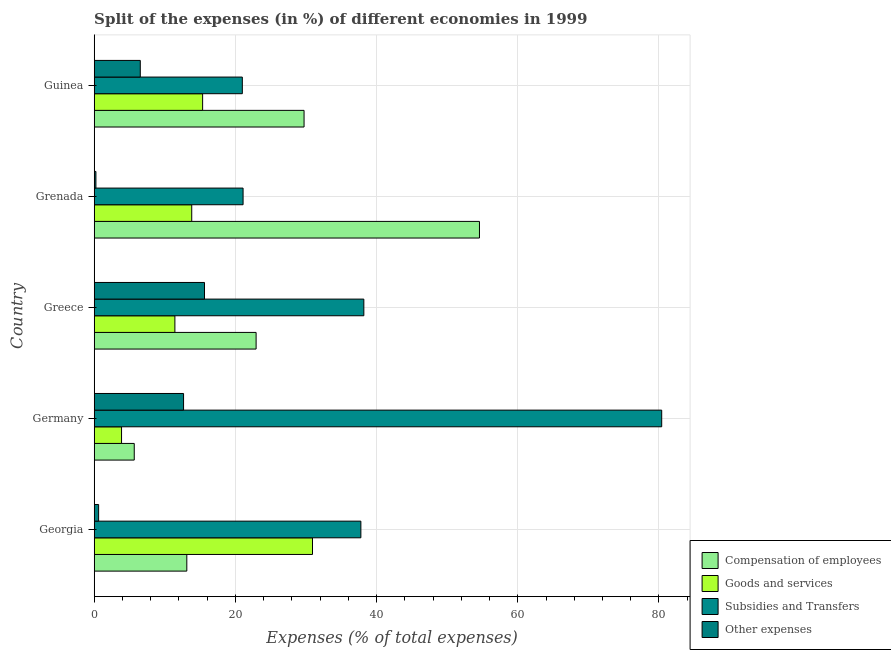What is the label of the 1st group of bars from the top?
Offer a terse response. Guinea. In how many cases, is the number of bars for a given country not equal to the number of legend labels?
Your response must be concise. 0. What is the percentage of amount spent on other expenses in Grenada?
Your response must be concise. 0.24. Across all countries, what is the maximum percentage of amount spent on compensation of employees?
Your answer should be compact. 54.57. Across all countries, what is the minimum percentage of amount spent on other expenses?
Provide a short and direct response. 0.24. In which country was the percentage of amount spent on goods and services maximum?
Your answer should be very brief. Georgia. In which country was the percentage of amount spent on goods and services minimum?
Your response must be concise. Germany. What is the total percentage of amount spent on subsidies in the graph?
Your answer should be very brief. 198.43. What is the difference between the percentage of amount spent on goods and services in Germany and that in Greece?
Offer a terse response. -7.56. What is the difference between the percentage of amount spent on subsidies in Grenada and the percentage of amount spent on compensation of employees in Georgia?
Make the answer very short. 7.97. What is the average percentage of amount spent on compensation of employees per country?
Your answer should be compact. 25.2. What is the difference between the percentage of amount spent on other expenses and percentage of amount spent on compensation of employees in Greece?
Keep it short and to the point. -7.31. In how many countries, is the percentage of amount spent on compensation of employees greater than 80 %?
Provide a short and direct response. 0. What is the ratio of the percentage of amount spent on goods and services in Georgia to that in Germany?
Make the answer very short. 7.98. Is the percentage of amount spent on goods and services in Grenada less than that in Guinea?
Provide a short and direct response. Yes. What is the difference between the highest and the second highest percentage of amount spent on subsidies?
Offer a very short reply. 42.19. What is the difference between the highest and the lowest percentage of amount spent on goods and services?
Keep it short and to the point. 27.05. Is the sum of the percentage of amount spent on compensation of employees in Georgia and Germany greater than the maximum percentage of amount spent on subsidies across all countries?
Your response must be concise. No. What does the 3rd bar from the top in Greece represents?
Give a very brief answer. Goods and services. What does the 2nd bar from the bottom in Greece represents?
Your answer should be very brief. Goods and services. Is it the case that in every country, the sum of the percentage of amount spent on compensation of employees and percentage of amount spent on goods and services is greater than the percentage of amount spent on subsidies?
Your answer should be compact. No. How many bars are there?
Give a very brief answer. 20. Are all the bars in the graph horizontal?
Offer a very short reply. Yes. How many countries are there in the graph?
Your answer should be compact. 5. What is the difference between two consecutive major ticks on the X-axis?
Offer a very short reply. 20. Does the graph contain any zero values?
Your answer should be very brief. No. Where does the legend appear in the graph?
Offer a very short reply. Bottom right. How many legend labels are there?
Give a very brief answer. 4. How are the legend labels stacked?
Provide a succinct answer. Vertical. What is the title of the graph?
Make the answer very short. Split of the expenses (in %) of different economies in 1999. Does "Fish species" appear as one of the legend labels in the graph?
Provide a succinct answer. No. What is the label or title of the X-axis?
Make the answer very short. Expenses (% of total expenses). What is the label or title of the Y-axis?
Your answer should be very brief. Country. What is the Expenses (% of total expenses) of Compensation of employees in Georgia?
Ensure brevity in your answer.  13.12. What is the Expenses (% of total expenses) of Goods and services in Georgia?
Provide a succinct answer. 30.92. What is the Expenses (% of total expenses) in Subsidies and Transfers in Georgia?
Give a very brief answer. 37.78. What is the Expenses (% of total expenses) of Other expenses in Georgia?
Your answer should be compact. 0.63. What is the Expenses (% of total expenses) in Compensation of employees in Germany?
Your answer should be very brief. 5.67. What is the Expenses (% of total expenses) of Goods and services in Germany?
Offer a very short reply. 3.87. What is the Expenses (% of total expenses) of Subsidies and Transfers in Germany?
Offer a terse response. 80.39. What is the Expenses (% of total expenses) of Other expenses in Germany?
Offer a terse response. 12.66. What is the Expenses (% of total expenses) of Compensation of employees in Greece?
Give a very brief answer. 22.93. What is the Expenses (% of total expenses) in Goods and services in Greece?
Give a very brief answer. 11.43. What is the Expenses (% of total expenses) in Subsidies and Transfers in Greece?
Make the answer very short. 38.2. What is the Expenses (% of total expenses) of Other expenses in Greece?
Ensure brevity in your answer.  15.62. What is the Expenses (% of total expenses) in Compensation of employees in Grenada?
Your answer should be compact. 54.57. What is the Expenses (% of total expenses) in Goods and services in Grenada?
Keep it short and to the point. 13.82. What is the Expenses (% of total expenses) in Subsidies and Transfers in Grenada?
Offer a terse response. 21.09. What is the Expenses (% of total expenses) in Other expenses in Grenada?
Your response must be concise. 0.24. What is the Expenses (% of total expenses) of Compensation of employees in Guinea?
Offer a very short reply. 29.73. What is the Expenses (% of total expenses) of Goods and services in Guinea?
Provide a short and direct response. 15.36. What is the Expenses (% of total expenses) of Subsidies and Transfers in Guinea?
Provide a short and direct response. 20.98. What is the Expenses (% of total expenses) of Other expenses in Guinea?
Offer a very short reply. 6.53. Across all countries, what is the maximum Expenses (% of total expenses) in Compensation of employees?
Provide a succinct answer. 54.57. Across all countries, what is the maximum Expenses (% of total expenses) in Goods and services?
Provide a short and direct response. 30.92. Across all countries, what is the maximum Expenses (% of total expenses) in Subsidies and Transfers?
Provide a short and direct response. 80.39. Across all countries, what is the maximum Expenses (% of total expenses) of Other expenses?
Make the answer very short. 15.62. Across all countries, what is the minimum Expenses (% of total expenses) of Compensation of employees?
Make the answer very short. 5.67. Across all countries, what is the minimum Expenses (% of total expenses) of Goods and services?
Make the answer very short. 3.87. Across all countries, what is the minimum Expenses (% of total expenses) of Subsidies and Transfers?
Offer a terse response. 20.98. Across all countries, what is the minimum Expenses (% of total expenses) in Other expenses?
Offer a very short reply. 0.24. What is the total Expenses (% of total expenses) of Compensation of employees in the graph?
Offer a terse response. 126.03. What is the total Expenses (% of total expenses) of Goods and services in the graph?
Your answer should be compact. 75.4. What is the total Expenses (% of total expenses) of Subsidies and Transfers in the graph?
Offer a very short reply. 198.43. What is the total Expenses (% of total expenses) in Other expenses in the graph?
Keep it short and to the point. 35.68. What is the difference between the Expenses (% of total expenses) of Compensation of employees in Georgia and that in Germany?
Offer a terse response. 7.44. What is the difference between the Expenses (% of total expenses) in Goods and services in Georgia and that in Germany?
Offer a terse response. 27.05. What is the difference between the Expenses (% of total expenses) of Subsidies and Transfers in Georgia and that in Germany?
Offer a terse response. -42.61. What is the difference between the Expenses (% of total expenses) of Other expenses in Georgia and that in Germany?
Ensure brevity in your answer.  -12.03. What is the difference between the Expenses (% of total expenses) in Compensation of employees in Georgia and that in Greece?
Keep it short and to the point. -9.82. What is the difference between the Expenses (% of total expenses) of Goods and services in Georgia and that in Greece?
Keep it short and to the point. 19.49. What is the difference between the Expenses (% of total expenses) of Subsidies and Transfers in Georgia and that in Greece?
Your response must be concise. -0.42. What is the difference between the Expenses (% of total expenses) in Other expenses in Georgia and that in Greece?
Provide a short and direct response. -15. What is the difference between the Expenses (% of total expenses) in Compensation of employees in Georgia and that in Grenada?
Keep it short and to the point. -41.46. What is the difference between the Expenses (% of total expenses) in Goods and services in Georgia and that in Grenada?
Provide a succinct answer. 17.11. What is the difference between the Expenses (% of total expenses) in Subsidies and Transfers in Georgia and that in Grenada?
Keep it short and to the point. 16.69. What is the difference between the Expenses (% of total expenses) of Other expenses in Georgia and that in Grenada?
Ensure brevity in your answer.  0.38. What is the difference between the Expenses (% of total expenses) of Compensation of employees in Georgia and that in Guinea?
Provide a succinct answer. -16.61. What is the difference between the Expenses (% of total expenses) in Goods and services in Georgia and that in Guinea?
Make the answer very short. 15.56. What is the difference between the Expenses (% of total expenses) of Subsidies and Transfers in Georgia and that in Guinea?
Provide a succinct answer. 16.79. What is the difference between the Expenses (% of total expenses) of Other expenses in Georgia and that in Guinea?
Your answer should be very brief. -5.9. What is the difference between the Expenses (% of total expenses) of Compensation of employees in Germany and that in Greece?
Provide a short and direct response. -17.26. What is the difference between the Expenses (% of total expenses) of Goods and services in Germany and that in Greece?
Your answer should be very brief. -7.56. What is the difference between the Expenses (% of total expenses) in Subsidies and Transfers in Germany and that in Greece?
Provide a short and direct response. 42.19. What is the difference between the Expenses (% of total expenses) in Other expenses in Germany and that in Greece?
Give a very brief answer. -2.97. What is the difference between the Expenses (% of total expenses) in Compensation of employees in Germany and that in Grenada?
Your answer should be very brief. -48.9. What is the difference between the Expenses (% of total expenses) of Goods and services in Germany and that in Grenada?
Give a very brief answer. -9.94. What is the difference between the Expenses (% of total expenses) of Subsidies and Transfers in Germany and that in Grenada?
Offer a terse response. 59.3. What is the difference between the Expenses (% of total expenses) of Other expenses in Germany and that in Grenada?
Your response must be concise. 12.41. What is the difference between the Expenses (% of total expenses) in Compensation of employees in Germany and that in Guinea?
Your answer should be very brief. -24.05. What is the difference between the Expenses (% of total expenses) in Goods and services in Germany and that in Guinea?
Make the answer very short. -11.48. What is the difference between the Expenses (% of total expenses) in Subsidies and Transfers in Germany and that in Guinea?
Your answer should be compact. 59.41. What is the difference between the Expenses (% of total expenses) in Other expenses in Germany and that in Guinea?
Give a very brief answer. 6.13. What is the difference between the Expenses (% of total expenses) in Compensation of employees in Greece and that in Grenada?
Ensure brevity in your answer.  -31.64. What is the difference between the Expenses (% of total expenses) of Goods and services in Greece and that in Grenada?
Ensure brevity in your answer.  -2.38. What is the difference between the Expenses (% of total expenses) of Subsidies and Transfers in Greece and that in Grenada?
Keep it short and to the point. 17.11. What is the difference between the Expenses (% of total expenses) of Other expenses in Greece and that in Grenada?
Make the answer very short. 15.38. What is the difference between the Expenses (% of total expenses) of Compensation of employees in Greece and that in Guinea?
Your answer should be compact. -6.79. What is the difference between the Expenses (% of total expenses) of Goods and services in Greece and that in Guinea?
Your response must be concise. -3.93. What is the difference between the Expenses (% of total expenses) in Subsidies and Transfers in Greece and that in Guinea?
Your answer should be compact. 17.21. What is the difference between the Expenses (% of total expenses) in Other expenses in Greece and that in Guinea?
Ensure brevity in your answer.  9.1. What is the difference between the Expenses (% of total expenses) in Compensation of employees in Grenada and that in Guinea?
Offer a very short reply. 24.85. What is the difference between the Expenses (% of total expenses) of Goods and services in Grenada and that in Guinea?
Provide a short and direct response. -1.54. What is the difference between the Expenses (% of total expenses) in Subsidies and Transfers in Grenada and that in Guinea?
Keep it short and to the point. 0.11. What is the difference between the Expenses (% of total expenses) of Other expenses in Grenada and that in Guinea?
Provide a short and direct response. -6.28. What is the difference between the Expenses (% of total expenses) of Compensation of employees in Georgia and the Expenses (% of total expenses) of Goods and services in Germany?
Provide a succinct answer. 9.24. What is the difference between the Expenses (% of total expenses) of Compensation of employees in Georgia and the Expenses (% of total expenses) of Subsidies and Transfers in Germany?
Your response must be concise. -67.27. What is the difference between the Expenses (% of total expenses) of Compensation of employees in Georgia and the Expenses (% of total expenses) of Other expenses in Germany?
Your answer should be very brief. 0.46. What is the difference between the Expenses (% of total expenses) of Goods and services in Georgia and the Expenses (% of total expenses) of Subsidies and Transfers in Germany?
Offer a terse response. -49.47. What is the difference between the Expenses (% of total expenses) in Goods and services in Georgia and the Expenses (% of total expenses) in Other expenses in Germany?
Ensure brevity in your answer.  18.26. What is the difference between the Expenses (% of total expenses) of Subsidies and Transfers in Georgia and the Expenses (% of total expenses) of Other expenses in Germany?
Provide a short and direct response. 25.12. What is the difference between the Expenses (% of total expenses) of Compensation of employees in Georgia and the Expenses (% of total expenses) of Goods and services in Greece?
Your answer should be very brief. 1.69. What is the difference between the Expenses (% of total expenses) of Compensation of employees in Georgia and the Expenses (% of total expenses) of Subsidies and Transfers in Greece?
Make the answer very short. -25.08. What is the difference between the Expenses (% of total expenses) of Compensation of employees in Georgia and the Expenses (% of total expenses) of Other expenses in Greece?
Offer a terse response. -2.51. What is the difference between the Expenses (% of total expenses) in Goods and services in Georgia and the Expenses (% of total expenses) in Subsidies and Transfers in Greece?
Offer a terse response. -7.27. What is the difference between the Expenses (% of total expenses) in Goods and services in Georgia and the Expenses (% of total expenses) in Other expenses in Greece?
Your response must be concise. 15.3. What is the difference between the Expenses (% of total expenses) of Subsidies and Transfers in Georgia and the Expenses (% of total expenses) of Other expenses in Greece?
Provide a short and direct response. 22.15. What is the difference between the Expenses (% of total expenses) of Compensation of employees in Georgia and the Expenses (% of total expenses) of Goods and services in Grenada?
Your answer should be very brief. -0.7. What is the difference between the Expenses (% of total expenses) in Compensation of employees in Georgia and the Expenses (% of total expenses) in Subsidies and Transfers in Grenada?
Make the answer very short. -7.97. What is the difference between the Expenses (% of total expenses) of Compensation of employees in Georgia and the Expenses (% of total expenses) of Other expenses in Grenada?
Provide a succinct answer. 12.87. What is the difference between the Expenses (% of total expenses) of Goods and services in Georgia and the Expenses (% of total expenses) of Subsidies and Transfers in Grenada?
Your response must be concise. 9.83. What is the difference between the Expenses (% of total expenses) in Goods and services in Georgia and the Expenses (% of total expenses) in Other expenses in Grenada?
Your response must be concise. 30.68. What is the difference between the Expenses (% of total expenses) of Subsidies and Transfers in Georgia and the Expenses (% of total expenses) of Other expenses in Grenada?
Your answer should be compact. 37.53. What is the difference between the Expenses (% of total expenses) in Compensation of employees in Georgia and the Expenses (% of total expenses) in Goods and services in Guinea?
Offer a very short reply. -2.24. What is the difference between the Expenses (% of total expenses) of Compensation of employees in Georgia and the Expenses (% of total expenses) of Subsidies and Transfers in Guinea?
Your response must be concise. -7.86. What is the difference between the Expenses (% of total expenses) in Compensation of employees in Georgia and the Expenses (% of total expenses) in Other expenses in Guinea?
Keep it short and to the point. 6.59. What is the difference between the Expenses (% of total expenses) in Goods and services in Georgia and the Expenses (% of total expenses) in Subsidies and Transfers in Guinea?
Keep it short and to the point. 9.94. What is the difference between the Expenses (% of total expenses) of Goods and services in Georgia and the Expenses (% of total expenses) of Other expenses in Guinea?
Provide a succinct answer. 24.39. What is the difference between the Expenses (% of total expenses) in Subsidies and Transfers in Georgia and the Expenses (% of total expenses) in Other expenses in Guinea?
Offer a terse response. 31.25. What is the difference between the Expenses (% of total expenses) of Compensation of employees in Germany and the Expenses (% of total expenses) of Goods and services in Greece?
Make the answer very short. -5.76. What is the difference between the Expenses (% of total expenses) of Compensation of employees in Germany and the Expenses (% of total expenses) of Subsidies and Transfers in Greece?
Make the answer very short. -32.52. What is the difference between the Expenses (% of total expenses) of Compensation of employees in Germany and the Expenses (% of total expenses) of Other expenses in Greece?
Offer a very short reply. -9.95. What is the difference between the Expenses (% of total expenses) of Goods and services in Germany and the Expenses (% of total expenses) of Subsidies and Transfers in Greece?
Your answer should be compact. -34.32. What is the difference between the Expenses (% of total expenses) of Goods and services in Germany and the Expenses (% of total expenses) of Other expenses in Greece?
Your response must be concise. -11.75. What is the difference between the Expenses (% of total expenses) in Subsidies and Transfers in Germany and the Expenses (% of total expenses) in Other expenses in Greece?
Your response must be concise. 64.77. What is the difference between the Expenses (% of total expenses) of Compensation of employees in Germany and the Expenses (% of total expenses) of Goods and services in Grenada?
Make the answer very short. -8.14. What is the difference between the Expenses (% of total expenses) in Compensation of employees in Germany and the Expenses (% of total expenses) in Subsidies and Transfers in Grenada?
Make the answer very short. -15.42. What is the difference between the Expenses (% of total expenses) of Compensation of employees in Germany and the Expenses (% of total expenses) of Other expenses in Grenada?
Give a very brief answer. 5.43. What is the difference between the Expenses (% of total expenses) of Goods and services in Germany and the Expenses (% of total expenses) of Subsidies and Transfers in Grenada?
Your answer should be very brief. -17.21. What is the difference between the Expenses (% of total expenses) of Goods and services in Germany and the Expenses (% of total expenses) of Other expenses in Grenada?
Your answer should be very brief. 3.63. What is the difference between the Expenses (% of total expenses) of Subsidies and Transfers in Germany and the Expenses (% of total expenses) of Other expenses in Grenada?
Provide a succinct answer. 80.15. What is the difference between the Expenses (% of total expenses) in Compensation of employees in Germany and the Expenses (% of total expenses) in Goods and services in Guinea?
Provide a succinct answer. -9.68. What is the difference between the Expenses (% of total expenses) in Compensation of employees in Germany and the Expenses (% of total expenses) in Subsidies and Transfers in Guinea?
Make the answer very short. -15.31. What is the difference between the Expenses (% of total expenses) in Compensation of employees in Germany and the Expenses (% of total expenses) in Other expenses in Guinea?
Your answer should be compact. -0.85. What is the difference between the Expenses (% of total expenses) of Goods and services in Germany and the Expenses (% of total expenses) of Subsidies and Transfers in Guinea?
Offer a terse response. -17.11. What is the difference between the Expenses (% of total expenses) in Goods and services in Germany and the Expenses (% of total expenses) in Other expenses in Guinea?
Offer a terse response. -2.65. What is the difference between the Expenses (% of total expenses) in Subsidies and Transfers in Germany and the Expenses (% of total expenses) in Other expenses in Guinea?
Your answer should be compact. 73.86. What is the difference between the Expenses (% of total expenses) in Compensation of employees in Greece and the Expenses (% of total expenses) in Goods and services in Grenada?
Keep it short and to the point. 9.12. What is the difference between the Expenses (% of total expenses) of Compensation of employees in Greece and the Expenses (% of total expenses) of Subsidies and Transfers in Grenada?
Keep it short and to the point. 1.85. What is the difference between the Expenses (% of total expenses) in Compensation of employees in Greece and the Expenses (% of total expenses) in Other expenses in Grenada?
Give a very brief answer. 22.69. What is the difference between the Expenses (% of total expenses) in Goods and services in Greece and the Expenses (% of total expenses) in Subsidies and Transfers in Grenada?
Keep it short and to the point. -9.66. What is the difference between the Expenses (% of total expenses) in Goods and services in Greece and the Expenses (% of total expenses) in Other expenses in Grenada?
Make the answer very short. 11.19. What is the difference between the Expenses (% of total expenses) of Subsidies and Transfers in Greece and the Expenses (% of total expenses) of Other expenses in Grenada?
Provide a short and direct response. 37.95. What is the difference between the Expenses (% of total expenses) in Compensation of employees in Greece and the Expenses (% of total expenses) in Goods and services in Guinea?
Provide a succinct answer. 7.58. What is the difference between the Expenses (% of total expenses) of Compensation of employees in Greece and the Expenses (% of total expenses) of Subsidies and Transfers in Guinea?
Provide a succinct answer. 1.95. What is the difference between the Expenses (% of total expenses) of Compensation of employees in Greece and the Expenses (% of total expenses) of Other expenses in Guinea?
Make the answer very short. 16.41. What is the difference between the Expenses (% of total expenses) of Goods and services in Greece and the Expenses (% of total expenses) of Subsidies and Transfers in Guinea?
Provide a short and direct response. -9.55. What is the difference between the Expenses (% of total expenses) in Goods and services in Greece and the Expenses (% of total expenses) in Other expenses in Guinea?
Your answer should be compact. 4.9. What is the difference between the Expenses (% of total expenses) of Subsidies and Transfers in Greece and the Expenses (% of total expenses) of Other expenses in Guinea?
Provide a short and direct response. 31.67. What is the difference between the Expenses (% of total expenses) in Compensation of employees in Grenada and the Expenses (% of total expenses) in Goods and services in Guinea?
Offer a terse response. 39.22. What is the difference between the Expenses (% of total expenses) in Compensation of employees in Grenada and the Expenses (% of total expenses) in Subsidies and Transfers in Guinea?
Your answer should be very brief. 33.59. What is the difference between the Expenses (% of total expenses) in Compensation of employees in Grenada and the Expenses (% of total expenses) in Other expenses in Guinea?
Keep it short and to the point. 48.05. What is the difference between the Expenses (% of total expenses) in Goods and services in Grenada and the Expenses (% of total expenses) in Subsidies and Transfers in Guinea?
Keep it short and to the point. -7.17. What is the difference between the Expenses (% of total expenses) in Goods and services in Grenada and the Expenses (% of total expenses) in Other expenses in Guinea?
Provide a short and direct response. 7.29. What is the difference between the Expenses (% of total expenses) of Subsidies and Transfers in Grenada and the Expenses (% of total expenses) of Other expenses in Guinea?
Your answer should be very brief. 14.56. What is the average Expenses (% of total expenses) of Compensation of employees per country?
Your answer should be very brief. 25.21. What is the average Expenses (% of total expenses) of Goods and services per country?
Ensure brevity in your answer.  15.08. What is the average Expenses (% of total expenses) of Subsidies and Transfers per country?
Your response must be concise. 39.69. What is the average Expenses (% of total expenses) of Other expenses per country?
Ensure brevity in your answer.  7.14. What is the difference between the Expenses (% of total expenses) of Compensation of employees and Expenses (% of total expenses) of Goods and services in Georgia?
Provide a short and direct response. -17.8. What is the difference between the Expenses (% of total expenses) of Compensation of employees and Expenses (% of total expenses) of Subsidies and Transfers in Georgia?
Your answer should be very brief. -24.66. What is the difference between the Expenses (% of total expenses) in Compensation of employees and Expenses (% of total expenses) in Other expenses in Georgia?
Ensure brevity in your answer.  12.49. What is the difference between the Expenses (% of total expenses) of Goods and services and Expenses (% of total expenses) of Subsidies and Transfers in Georgia?
Keep it short and to the point. -6.85. What is the difference between the Expenses (% of total expenses) in Goods and services and Expenses (% of total expenses) in Other expenses in Georgia?
Ensure brevity in your answer.  30.3. What is the difference between the Expenses (% of total expenses) in Subsidies and Transfers and Expenses (% of total expenses) in Other expenses in Georgia?
Keep it short and to the point. 37.15. What is the difference between the Expenses (% of total expenses) in Compensation of employees and Expenses (% of total expenses) in Goods and services in Germany?
Provide a short and direct response. 1.8. What is the difference between the Expenses (% of total expenses) of Compensation of employees and Expenses (% of total expenses) of Subsidies and Transfers in Germany?
Make the answer very short. -74.72. What is the difference between the Expenses (% of total expenses) in Compensation of employees and Expenses (% of total expenses) in Other expenses in Germany?
Provide a short and direct response. -6.98. What is the difference between the Expenses (% of total expenses) in Goods and services and Expenses (% of total expenses) in Subsidies and Transfers in Germany?
Provide a succinct answer. -76.52. What is the difference between the Expenses (% of total expenses) of Goods and services and Expenses (% of total expenses) of Other expenses in Germany?
Offer a terse response. -8.78. What is the difference between the Expenses (% of total expenses) in Subsidies and Transfers and Expenses (% of total expenses) in Other expenses in Germany?
Make the answer very short. 67.73. What is the difference between the Expenses (% of total expenses) in Compensation of employees and Expenses (% of total expenses) in Goods and services in Greece?
Make the answer very short. 11.5. What is the difference between the Expenses (% of total expenses) of Compensation of employees and Expenses (% of total expenses) of Subsidies and Transfers in Greece?
Your answer should be very brief. -15.26. What is the difference between the Expenses (% of total expenses) in Compensation of employees and Expenses (% of total expenses) in Other expenses in Greece?
Make the answer very short. 7.31. What is the difference between the Expenses (% of total expenses) in Goods and services and Expenses (% of total expenses) in Subsidies and Transfers in Greece?
Offer a terse response. -26.77. What is the difference between the Expenses (% of total expenses) in Goods and services and Expenses (% of total expenses) in Other expenses in Greece?
Provide a succinct answer. -4.19. What is the difference between the Expenses (% of total expenses) of Subsidies and Transfers and Expenses (% of total expenses) of Other expenses in Greece?
Your answer should be compact. 22.57. What is the difference between the Expenses (% of total expenses) in Compensation of employees and Expenses (% of total expenses) in Goods and services in Grenada?
Make the answer very short. 40.76. What is the difference between the Expenses (% of total expenses) in Compensation of employees and Expenses (% of total expenses) in Subsidies and Transfers in Grenada?
Offer a very short reply. 33.49. What is the difference between the Expenses (% of total expenses) in Compensation of employees and Expenses (% of total expenses) in Other expenses in Grenada?
Your answer should be very brief. 54.33. What is the difference between the Expenses (% of total expenses) in Goods and services and Expenses (% of total expenses) in Subsidies and Transfers in Grenada?
Ensure brevity in your answer.  -7.27. What is the difference between the Expenses (% of total expenses) of Goods and services and Expenses (% of total expenses) of Other expenses in Grenada?
Your answer should be compact. 13.57. What is the difference between the Expenses (% of total expenses) in Subsidies and Transfers and Expenses (% of total expenses) in Other expenses in Grenada?
Your response must be concise. 20.84. What is the difference between the Expenses (% of total expenses) of Compensation of employees and Expenses (% of total expenses) of Goods and services in Guinea?
Provide a short and direct response. 14.37. What is the difference between the Expenses (% of total expenses) of Compensation of employees and Expenses (% of total expenses) of Subsidies and Transfers in Guinea?
Ensure brevity in your answer.  8.74. What is the difference between the Expenses (% of total expenses) in Compensation of employees and Expenses (% of total expenses) in Other expenses in Guinea?
Provide a short and direct response. 23.2. What is the difference between the Expenses (% of total expenses) in Goods and services and Expenses (% of total expenses) in Subsidies and Transfers in Guinea?
Offer a very short reply. -5.62. What is the difference between the Expenses (% of total expenses) of Goods and services and Expenses (% of total expenses) of Other expenses in Guinea?
Offer a terse response. 8.83. What is the difference between the Expenses (% of total expenses) of Subsidies and Transfers and Expenses (% of total expenses) of Other expenses in Guinea?
Offer a very short reply. 14.45. What is the ratio of the Expenses (% of total expenses) of Compensation of employees in Georgia to that in Germany?
Provide a short and direct response. 2.31. What is the ratio of the Expenses (% of total expenses) of Goods and services in Georgia to that in Germany?
Offer a terse response. 7.98. What is the ratio of the Expenses (% of total expenses) of Subsidies and Transfers in Georgia to that in Germany?
Make the answer very short. 0.47. What is the ratio of the Expenses (% of total expenses) of Other expenses in Georgia to that in Germany?
Your answer should be compact. 0.05. What is the ratio of the Expenses (% of total expenses) of Compensation of employees in Georgia to that in Greece?
Your answer should be compact. 0.57. What is the ratio of the Expenses (% of total expenses) of Goods and services in Georgia to that in Greece?
Provide a succinct answer. 2.71. What is the ratio of the Expenses (% of total expenses) in Subsidies and Transfers in Georgia to that in Greece?
Make the answer very short. 0.99. What is the ratio of the Expenses (% of total expenses) in Other expenses in Georgia to that in Greece?
Make the answer very short. 0.04. What is the ratio of the Expenses (% of total expenses) of Compensation of employees in Georgia to that in Grenada?
Provide a succinct answer. 0.24. What is the ratio of the Expenses (% of total expenses) of Goods and services in Georgia to that in Grenada?
Your answer should be compact. 2.24. What is the ratio of the Expenses (% of total expenses) of Subsidies and Transfers in Georgia to that in Grenada?
Provide a succinct answer. 1.79. What is the ratio of the Expenses (% of total expenses) of Other expenses in Georgia to that in Grenada?
Your answer should be very brief. 2.56. What is the ratio of the Expenses (% of total expenses) in Compensation of employees in Georgia to that in Guinea?
Provide a succinct answer. 0.44. What is the ratio of the Expenses (% of total expenses) of Goods and services in Georgia to that in Guinea?
Provide a short and direct response. 2.01. What is the ratio of the Expenses (% of total expenses) in Subsidies and Transfers in Georgia to that in Guinea?
Offer a terse response. 1.8. What is the ratio of the Expenses (% of total expenses) of Other expenses in Georgia to that in Guinea?
Offer a terse response. 0.1. What is the ratio of the Expenses (% of total expenses) of Compensation of employees in Germany to that in Greece?
Provide a succinct answer. 0.25. What is the ratio of the Expenses (% of total expenses) of Goods and services in Germany to that in Greece?
Provide a short and direct response. 0.34. What is the ratio of the Expenses (% of total expenses) of Subsidies and Transfers in Germany to that in Greece?
Your answer should be compact. 2.1. What is the ratio of the Expenses (% of total expenses) in Other expenses in Germany to that in Greece?
Your answer should be very brief. 0.81. What is the ratio of the Expenses (% of total expenses) in Compensation of employees in Germany to that in Grenada?
Your response must be concise. 0.1. What is the ratio of the Expenses (% of total expenses) of Goods and services in Germany to that in Grenada?
Give a very brief answer. 0.28. What is the ratio of the Expenses (% of total expenses) in Subsidies and Transfers in Germany to that in Grenada?
Make the answer very short. 3.81. What is the ratio of the Expenses (% of total expenses) in Other expenses in Germany to that in Grenada?
Offer a terse response. 51.83. What is the ratio of the Expenses (% of total expenses) of Compensation of employees in Germany to that in Guinea?
Ensure brevity in your answer.  0.19. What is the ratio of the Expenses (% of total expenses) of Goods and services in Germany to that in Guinea?
Provide a short and direct response. 0.25. What is the ratio of the Expenses (% of total expenses) in Subsidies and Transfers in Germany to that in Guinea?
Your answer should be compact. 3.83. What is the ratio of the Expenses (% of total expenses) of Other expenses in Germany to that in Guinea?
Make the answer very short. 1.94. What is the ratio of the Expenses (% of total expenses) in Compensation of employees in Greece to that in Grenada?
Provide a succinct answer. 0.42. What is the ratio of the Expenses (% of total expenses) of Goods and services in Greece to that in Grenada?
Ensure brevity in your answer.  0.83. What is the ratio of the Expenses (% of total expenses) in Subsidies and Transfers in Greece to that in Grenada?
Keep it short and to the point. 1.81. What is the ratio of the Expenses (% of total expenses) in Other expenses in Greece to that in Grenada?
Keep it short and to the point. 63.97. What is the ratio of the Expenses (% of total expenses) of Compensation of employees in Greece to that in Guinea?
Keep it short and to the point. 0.77. What is the ratio of the Expenses (% of total expenses) of Goods and services in Greece to that in Guinea?
Your answer should be compact. 0.74. What is the ratio of the Expenses (% of total expenses) of Subsidies and Transfers in Greece to that in Guinea?
Make the answer very short. 1.82. What is the ratio of the Expenses (% of total expenses) in Other expenses in Greece to that in Guinea?
Your answer should be very brief. 2.39. What is the ratio of the Expenses (% of total expenses) of Compensation of employees in Grenada to that in Guinea?
Your answer should be very brief. 1.84. What is the ratio of the Expenses (% of total expenses) in Goods and services in Grenada to that in Guinea?
Your answer should be compact. 0.9. What is the ratio of the Expenses (% of total expenses) of Subsidies and Transfers in Grenada to that in Guinea?
Keep it short and to the point. 1.01. What is the ratio of the Expenses (% of total expenses) in Other expenses in Grenada to that in Guinea?
Your response must be concise. 0.04. What is the difference between the highest and the second highest Expenses (% of total expenses) in Compensation of employees?
Provide a succinct answer. 24.85. What is the difference between the highest and the second highest Expenses (% of total expenses) of Goods and services?
Offer a very short reply. 15.56. What is the difference between the highest and the second highest Expenses (% of total expenses) of Subsidies and Transfers?
Offer a very short reply. 42.19. What is the difference between the highest and the second highest Expenses (% of total expenses) in Other expenses?
Your answer should be compact. 2.97. What is the difference between the highest and the lowest Expenses (% of total expenses) of Compensation of employees?
Ensure brevity in your answer.  48.9. What is the difference between the highest and the lowest Expenses (% of total expenses) of Goods and services?
Ensure brevity in your answer.  27.05. What is the difference between the highest and the lowest Expenses (% of total expenses) in Subsidies and Transfers?
Your answer should be compact. 59.41. What is the difference between the highest and the lowest Expenses (% of total expenses) in Other expenses?
Provide a short and direct response. 15.38. 